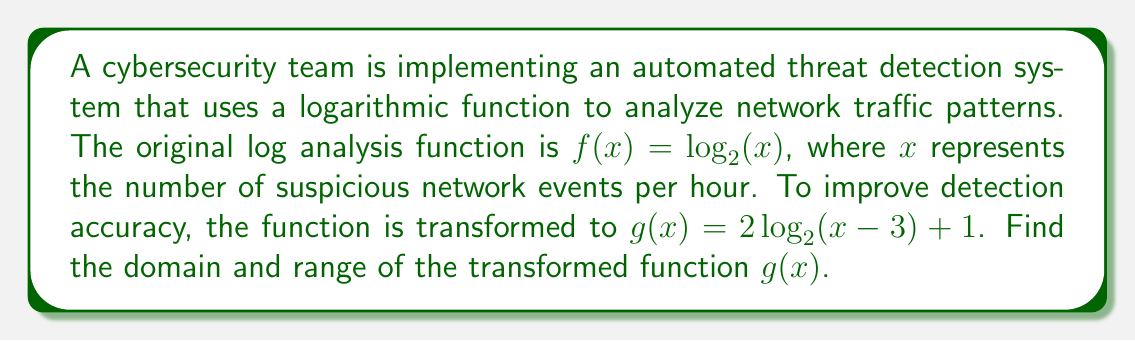Give your solution to this math problem. To find the domain and range of the transformed function $g(x) = 2\log_2(x-3) + 1$, we need to analyze each transformation step:

1. Inside transformation: $(x-3)$
   - This shifts the function 3 units to the right.
   - The domain of $\log_2(x)$ is $x > 0$, so we need $(x-3) > 0$
   - Solving this: $x-3 > 0$, $x > 3$

2. Outside transformations:
   a. Vertical stretch by a factor of 2: $2\log_2(x-3)$
   b. Vertical shift up by 1 unit: $2\log_2(x-3) + 1$

These outside transformations don't affect the domain but will impact the range.

For the range:
- The original $\log_2(x)$ function has a range of all real numbers.
- The vertical stretch by 2 will double all y-values.
- The vertical shift by 1 will move all points up by 1 unit.

To find the y-intercept of $g(x)$, we can calculate the limit as $x$ approaches the left bound of the domain:

$\lim_{x \to 3^+} g(x) = \lim_{x \to 3^+} (2\log_2(x-3) + 1)$

As $x$ approaches 3 from the right, $\log_2(x-3)$ approaches negative infinity. When multiplied by 2 and added to 1, the result still approaches negative infinity.

Therefore, the range of $g(x)$ is all real numbers greater than 1 (excluding 1 itself).
Answer: Domain: $x > 3$
Range: $y > 1$ 